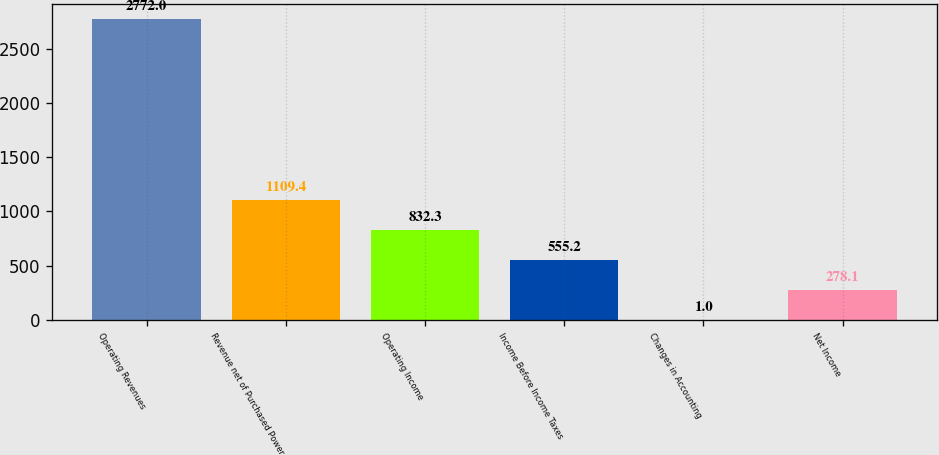Convert chart. <chart><loc_0><loc_0><loc_500><loc_500><bar_chart><fcel>Operating Revenues<fcel>Revenue net of Purchased Power<fcel>Operating Income<fcel>Income Before Income Taxes<fcel>Changes in Accounting<fcel>Net Income<nl><fcel>2772<fcel>1109.4<fcel>832.3<fcel>555.2<fcel>1<fcel>278.1<nl></chart> 